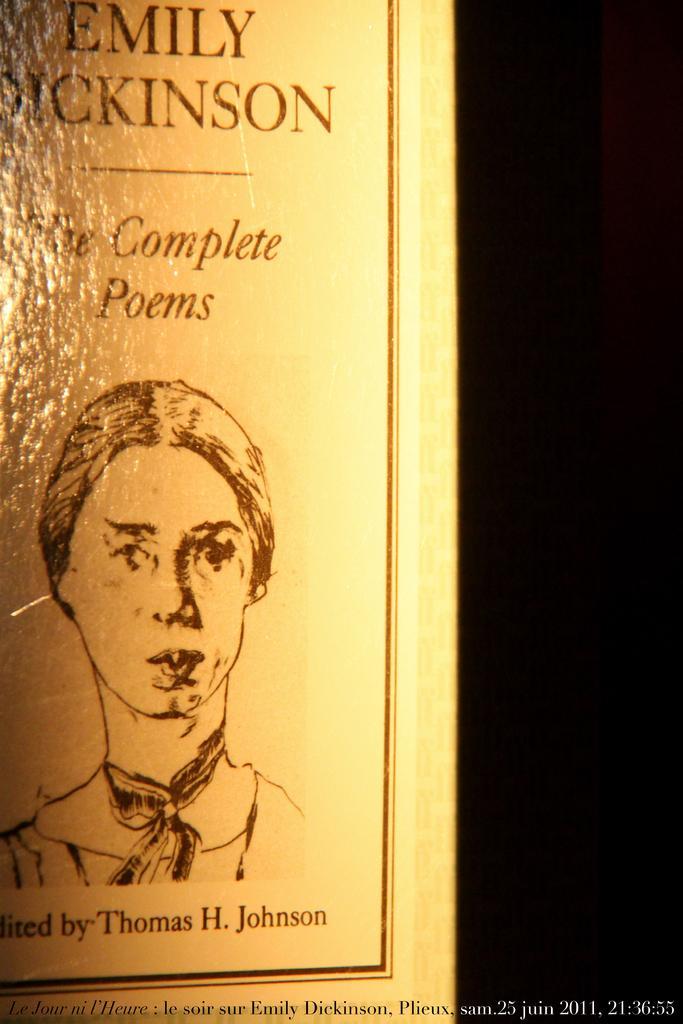Can you describe this image briefly? In the center of the image we can see one poster. On the poster, we can see one person. And we can see some text on the poster. In the bottom of the image, we can see some text. 